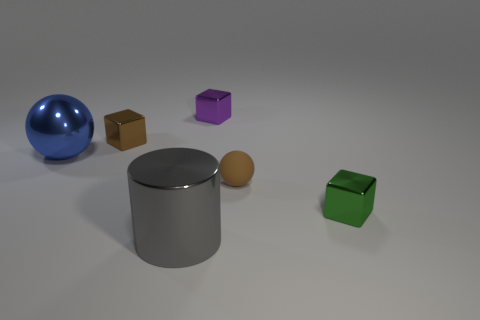Add 3 small metallic blocks. How many objects exist? 9 Subtract 1 blocks. How many blocks are left? 2 Subtract all tiny green cubes. How many cubes are left? 2 Subtract all cylinders. How many objects are left? 5 Subtract 1 blue spheres. How many objects are left? 5 Subtract all big red rubber balls. Subtract all large gray shiny cylinders. How many objects are left? 5 Add 2 blue objects. How many blue objects are left? 3 Add 5 rubber things. How many rubber things exist? 6 